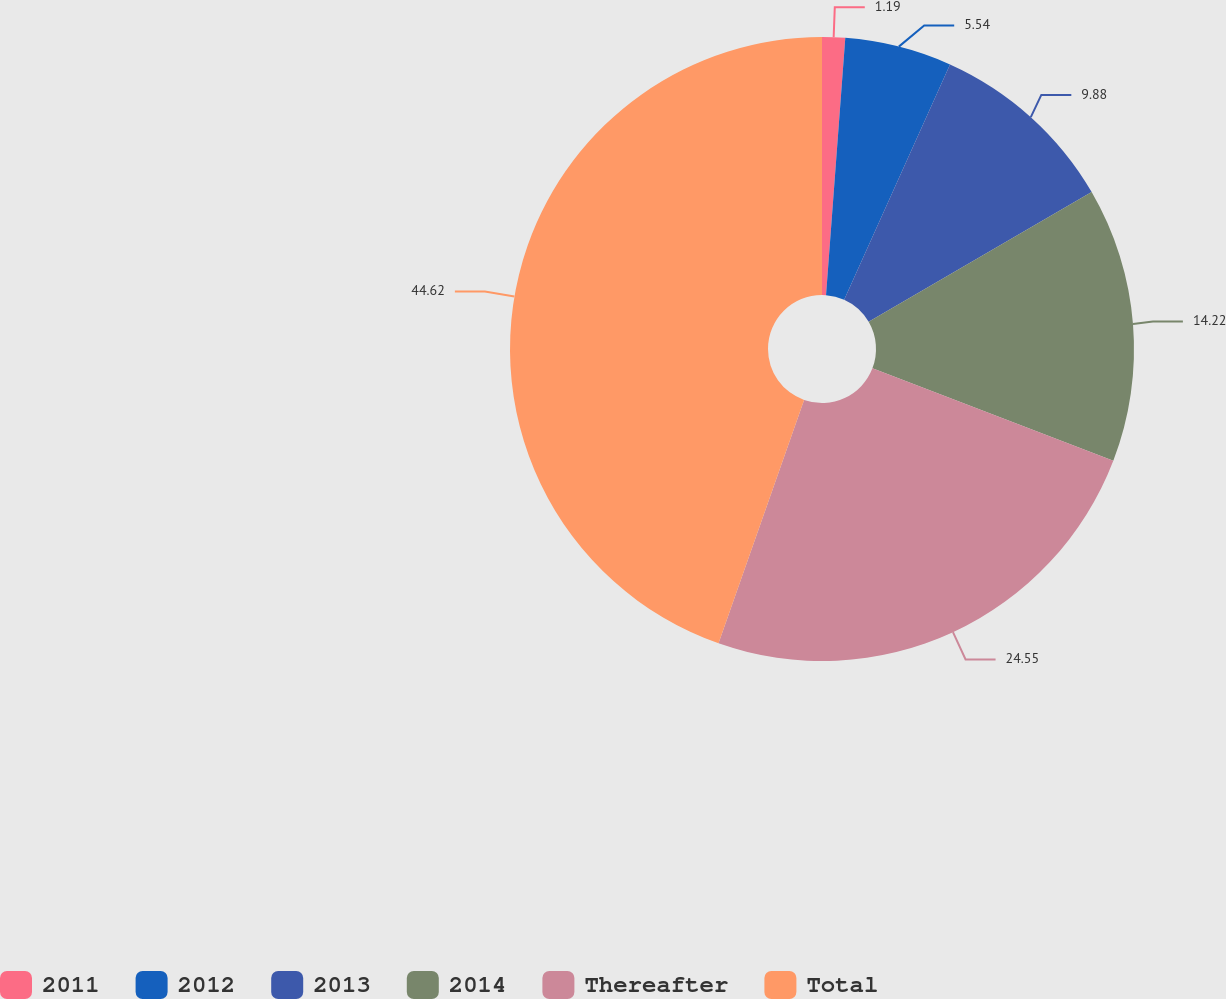Convert chart to OTSL. <chart><loc_0><loc_0><loc_500><loc_500><pie_chart><fcel>2011<fcel>2012<fcel>2013<fcel>2014<fcel>Thereafter<fcel>Total<nl><fcel>1.19%<fcel>5.54%<fcel>9.88%<fcel>14.22%<fcel>24.55%<fcel>44.62%<nl></chart> 